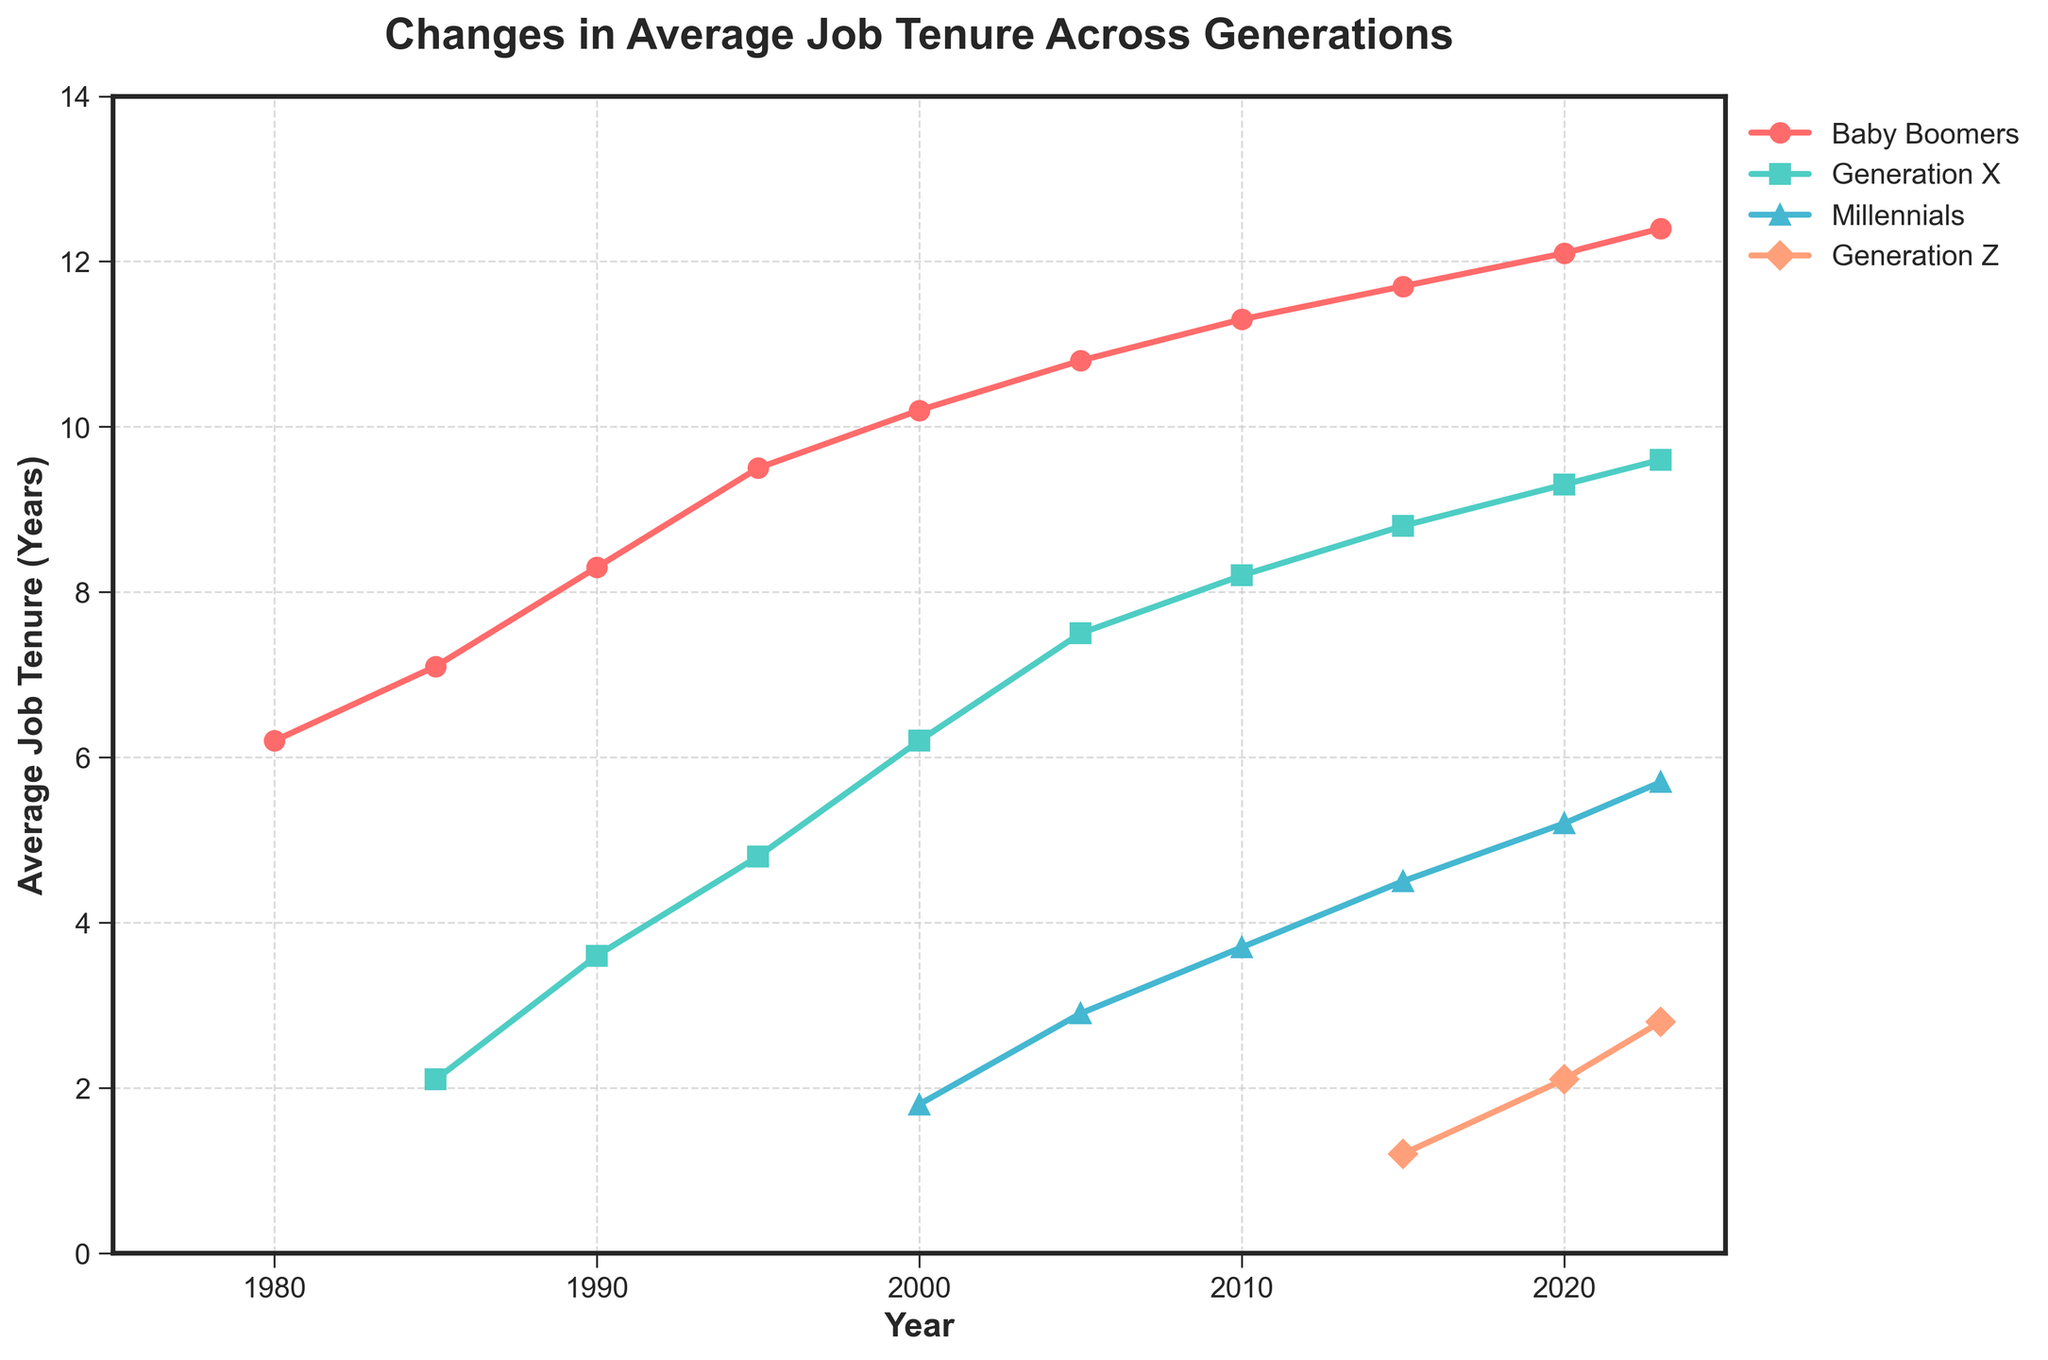What's the average job tenure of Millennials in 2010 and 2015? Add the job tenures of Millennials in 2010 (3.7 years) and 2015 (4.5 years), then divide by 2. (3.7 + 4.5) / 2 = 4.1
Answer: 4.1 years Which generation had the longest job tenure in 2000? Look at the values for each generation in 2000 and compare. Baby Boomers had 10.2, Gen X had 6.2, and Millennials had 1.8. Baby Boomers had the longest tenure.
Answer: Baby Boomers How did the average job tenure for Gen X change from 1995 to 2023? Subtract the job tenure of Gen X in 1995 from the job tenure in 2023. 9.6 - 4.8 = 4.8
Answer: Increased by 4.8 years Which generation had the steepest increase in job tenure from 2015 to 2020? Calculate the difference in job tenure for all generations between 2015 and 2020. Baby Boomers: 0.4, Gen X: 0.5, Millennials: 0.7, Gen Z: 0.9. Gen Z had the steepest increase.
Answer: Generation Z What is the total job tenure for Baby Boomers, Gen X, and Millennials combined in 2010? Add the job tenure values for each group in 2010. 11.3 (Baby Boomers) + 8.2 (Gen X) + 3.7 (Millennials) = 23.2
Answer: 23.2 years Between which two generations was the job tenure difference the greatest in 2023? Calculate the differences between each pair of generations for 2023. Baby Boomers & Gen X: 12.4 - 9.6 = 2.8, Baby Boomers & Millennials: 12.4 - 5.7 = 6.7, Baby Boomers & Gen Z: 12.4 - 2.8 = 9.6, Gen X & Millennials: 9.6 - 5.7 = 3.9, Gen X & Gen Z: 9.6 - 2.8 = 6.8, Millennials & Gen Z: 5.7 - 2.8 = 2.9. The greatest difference is between Baby Boomers and Gen Z.
Answer: Baby Boomers and Gen Z From 1980 to 2023, which generation showed a consistent increase in job tenure? Observe the plot for each generation across the years to see if the tenure consistently increases without any decreases. Baby Boomers consistently increased.
Answer: Baby Boomers What color is used to represent Millennials on the graph? Refer to the color of the line associated with Millennials in the legend of the graph.
Answer: Blue Is there any year where Generation Z had a higher job tenure than Millennials? Compare the job tenure values for Generation Z and Millennials for each year they are both present. At no point does Generation Z's tenure surpass Millennials.
Answer: No 